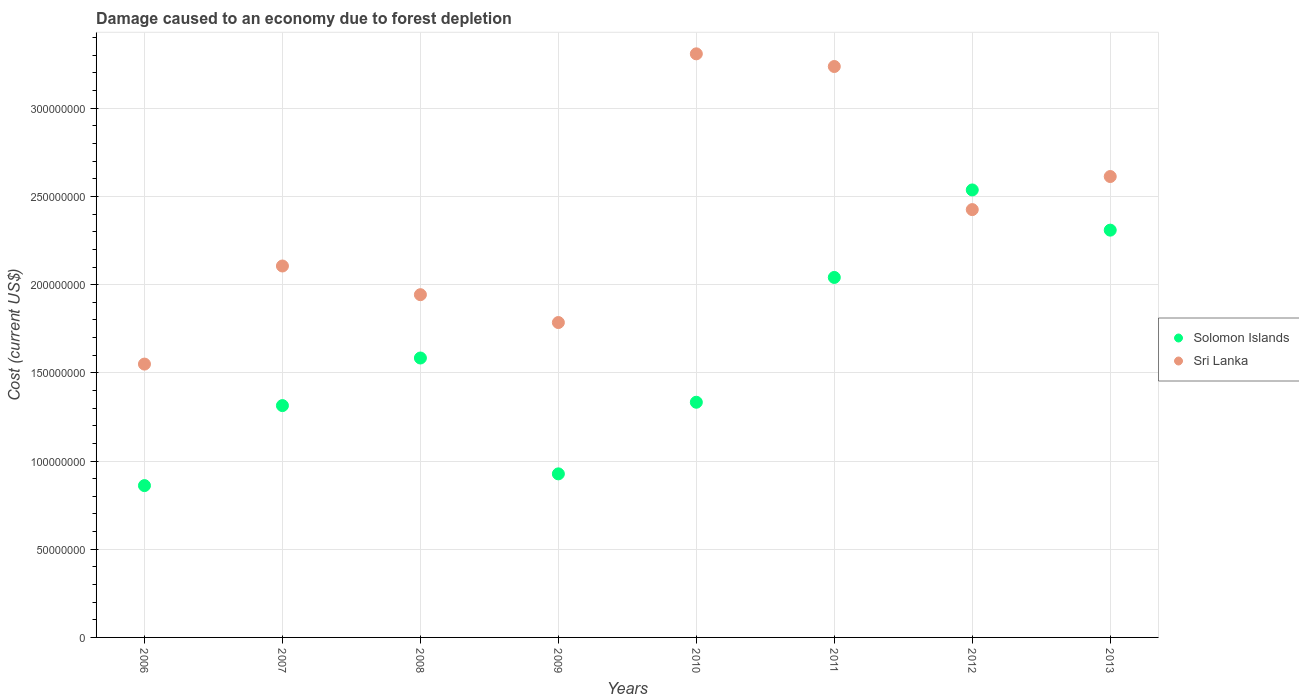Is the number of dotlines equal to the number of legend labels?
Provide a short and direct response. Yes. What is the cost of damage caused due to forest depletion in Solomon Islands in 2010?
Your answer should be very brief. 1.33e+08. Across all years, what is the maximum cost of damage caused due to forest depletion in Solomon Islands?
Make the answer very short. 2.54e+08. Across all years, what is the minimum cost of damage caused due to forest depletion in Solomon Islands?
Give a very brief answer. 8.61e+07. In which year was the cost of damage caused due to forest depletion in Solomon Islands maximum?
Your answer should be very brief. 2012. What is the total cost of damage caused due to forest depletion in Sri Lanka in the graph?
Provide a short and direct response. 1.90e+09. What is the difference between the cost of damage caused due to forest depletion in Solomon Islands in 2006 and that in 2010?
Provide a short and direct response. -4.73e+07. What is the difference between the cost of damage caused due to forest depletion in Sri Lanka in 2006 and the cost of damage caused due to forest depletion in Solomon Islands in 2008?
Ensure brevity in your answer.  -3.45e+06. What is the average cost of damage caused due to forest depletion in Sri Lanka per year?
Keep it short and to the point. 2.37e+08. In the year 2011, what is the difference between the cost of damage caused due to forest depletion in Sri Lanka and cost of damage caused due to forest depletion in Solomon Islands?
Give a very brief answer. 1.20e+08. In how many years, is the cost of damage caused due to forest depletion in Solomon Islands greater than 150000000 US$?
Ensure brevity in your answer.  4. What is the ratio of the cost of damage caused due to forest depletion in Sri Lanka in 2009 to that in 2011?
Provide a succinct answer. 0.55. Is the cost of damage caused due to forest depletion in Solomon Islands in 2009 less than that in 2011?
Keep it short and to the point. Yes. Is the difference between the cost of damage caused due to forest depletion in Sri Lanka in 2006 and 2010 greater than the difference between the cost of damage caused due to forest depletion in Solomon Islands in 2006 and 2010?
Give a very brief answer. No. What is the difference between the highest and the second highest cost of damage caused due to forest depletion in Solomon Islands?
Give a very brief answer. 2.28e+07. What is the difference between the highest and the lowest cost of damage caused due to forest depletion in Solomon Islands?
Ensure brevity in your answer.  1.68e+08. In how many years, is the cost of damage caused due to forest depletion in Sri Lanka greater than the average cost of damage caused due to forest depletion in Sri Lanka taken over all years?
Ensure brevity in your answer.  4. Is the sum of the cost of damage caused due to forest depletion in Solomon Islands in 2008 and 2011 greater than the maximum cost of damage caused due to forest depletion in Sri Lanka across all years?
Your response must be concise. Yes. Is the cost of damage caused due to forest depletion in Solomon Islands strictly greater than the cost of damage caused due to forest depletion in Sri Lanka over the years?
Offer a terse response. No. How many years are there in the graph?
Ensure brevity in your answer.  8. Are the values on the major ticks of Y-axis written in scientific E-notation?
Provide a short and direct response. No. Does the graph contain grids?
Give a very brief answer. Yes. Where does the legend appear in the graph?
Provide a succinct answer. Center right. What is the title of the graph?
Give a very brief answer. Damage caused to an economy due to forest depletion. What is the label or title of the Y-axis?
Your response must be concise. Cost (current US$). What is the Cost (current US$) of Solomon Islands in 2006?
Keep it short and to the point. 8.61e+07. What is the Cost (current US$) of Sri Lanka in 2006?
Offer a very short reply. 1.55e+08. What is the Cost (current US$) of Solomon Islands in 2007?
Your response must be concise. 1.31e+08. What is the Cost (current US$) in Sri Lanka in 2007?
Your answer should be compact. 2.11e+08. What is the Cost (current US$) in Solomon Islands in 2008?
Provide a short and direct response. 1.58e+08. What is the Cost (current US$) in Sri Lanka in 2008?
Your answer should be compact. 1.94e+08. What is the Cost (current US$) of Solomon Islands in 2009?
Make the answer very short. 9.27e+07. What is the Cost (current US$) in Sri Lanka in 2009?
Your answer should be very brief. 1.79e+08. What is the Cost (current US$) of Solomon Islands in 2010?
Ensure brevity in your answer.  1.33e+08. What is the Cost (current US$) in Sri Lanka in 2010?
Your response must be concise. 3.31e+08. What is the Cost (current US$) in Solomon Islands in 2011?
Ensure brevity in your answer.  2.04e+08. What is the Cost (current US$) of Sri Lanka in 2011?
Your answer should be compact. 3.24e+08. What is the Cost (current US$) in Solomon Islands in 2012?
Provide a succinct answer. 2.54e+08. What is the Cost (current US$) in Sri Lanka in 2012?
Your response must be concise. 2.43e+08. What is the Cost (current US$) in Solomon Islands in 2013?
Offer a very short reply. 2.31e+08. What is the Cost (current US$) in Sri Lanka in 2013?
Keep it short and to the point. 2.61e+08. Across all years, what is the maximum Cost (current US$) of Solomon Islands?
Your response must be concise. 2.54e+08. Across all years, what is the maximum Cost (current US$) in Sri Lanka?
Provide a succinct answer. 3.31e+08. Across all years, what is the minimum Cost (current US$) in Solomon Islands?
Offer a terse response. 8.61e+07. Across all years, what is the minimum Cost (current US$) in Sri Lanka?
Keep it short and to the point. 1.55e+08. What is the total Cost (current US$) in Solomon Islands in the graph?
Provide a succinct answer. 1.29e+09. What is the total Cost (current US$) in Sri Lanka in the graph?
Keep it short and to the point. 1.90e+09. What is the difference between the Cost (current US$) in Solomon Islands in 2006 and that in 2007?
Keep it short and to the point. -4.54e+07. What is the difference between the Cost (current US$) of Sri Lanka in 2006 and that in 2007?
Ensure brevity in your answer.  -5.56e+07. What is the difference between the Cost (current US$) in Solomon Islands in 2006 and that in 2008?
Your answer should be very brief. -7.23e+07. What is the difference between the Cost (current US$) in Sri Lanka in 2006 and that in 2008?
Make the answer very short. -3.93e+07. What is the difference between the Cost (current US$) in Solomon Islands in 2006 and that in 2009?
Your answer should be compact. -6.65e+06. What is the difference between the Cost (current US$) of Sri Lanka in 2006 and that in 2009?
Your answer should be very brief. -2.36e+07. What is the difference between the Cost (current US$) of Solomon Islands in 2006 and that in 2010?
Your answer should be very brief. -4.73e+07. What is the difference between the Cost (current US$) of Sri Lanka in 2006 and that in 2010?
Give a very brief answer. -1.76e+08. What is the difference between the Cost (current US$) in Solomon Islands in 2006 and that in 2011?
Your answer should be very brief. -1.18e+08. What is the difference between the Cost (current US$) of Sri Lanka in 2006 and that in 2011?
Provide a short and direct response. -1.69e+08. What is the difference between the Cost (current US$) of Solomon Islands in 2006 and that in 2012?
Provide a succinct answer. -1.68e+08. What is the difference between the Cost (current US$) in Sri Lanka in 2006 and that in 2012?
Your answer should be very brief. -8.76e+07. What is the difference between the Cost (current US$) of Solomon Islands in 2006 and that in 2013?
Give a very brief answer. -1.45e+08. What is the difference between the Cost (current US$) of Sri Lanka in 2006 and that in 2013?
Provide a succinct answer. -1.06e+08. What is the difference between the Cost (current US$) in Solomon Islands in 2007 and that in 2008?
Your response must be concise. -2.70e+07. What is the difference between the Cost (current US$) in Sri Lanka in 2007 and that in 2008?
Provide a short and direct response. 1.63e+07. What is the difference between the Cost (current US$) of Solomon Islands in 2007 and that in 2009?
Your answer should be compact. 3.87e+07. What is the difference between the Cost (current US$) in Sri Lanka in 2007 and that in 2009?
Keep it short and to the point. 3.21e+07. What is the difference between the Cost (current US$) of Solomon Islands in 2007 and that in 2010?
Offer a terse response. -1.90e+06. What is the difference between the Cost (current US$) in Sri Lanka in 2007 and that in 2010?
Offer a very short reply. -1.20e+08. What is the difference between the Cost (current US$) in Solomon Islands in 2007 and that in 2011?
Provide a succinct answer. -7.27e+07. What is the difference between the Cost (current US$) in Sri Lanka in 2007 and that in 2011?
Your answer should be compact. -1.13e+08. What is the difference between the Cost (current US$) in Solomon Islands in 2007 and that in 2012?
Your answer should be very brief. -1.22e+08. What is the difference between the Cost (current US$) of Sri Lanka in 2007 and that in 2012?
Your answer should be compact. -3.20e+07. What is the difference between the Cost (current US$) of Solomon Islands in 2007 and that in 2013?
Your answer should be very brief. -9.95e+07. What is the difference between the Cost (current US$) of Sri Lanka in 2007 and that in 2013?
Give a very brief answer. -5.07e+07. What is the difference between the Cost (current US$) in Solomon Islands in 2008 and that in 2009?
Ensure brevity in your answer.  6.57e+07. What is the difference between the Cost (current US$) of Sri Lanka in 2008 and that in 2009?
Offer a very short reply. 1.58e+07. What is the difference between the Cost (current US$) in Solomon Islands in 2008 and that in 2010?
Offer a very short reply. 2.51e+07. What is the difference between the Cost (current US$) in Sri Lanka in 2008 and that in 2010?
Provide a succinct answer. -1.37e+08. What is the difference between the Cost (current US$) in Solomon Islands in 2008 and that in 2011?
Ensure brevity in your answer.  -4.57e+07. What is the difference between the Cost (current US$) in Sri Lanka in 2008 and that in 2011?
Give a very brief answer. -1.29e+08. What is the difference between the Cost (current US$) in Solomon Islands in 2008 and that in 2012?
Provide a succinct answer. -9.53e+07. What is the difference between the Cost (current US$) of Sri Lanka in 2008 and that in 2012?
Keep it short and to the point. -4.82e+07. What is the difference between the Cost (current US$) of Solomon Islands in 2008 and that in 2013?
Give a very brief answer. -7.25e+07. What is the difference between the Cost (current US$) in Sri Lanka in 2008 and that in 2013?
Make the answer very short. -6.70e+07. What is the difference between the Cost (current US$) of Solomon Islands in 2009 and that in 2010?
Provide a short and direct response. -4.06e+07. What is the difference between the Cost (current US$) in Sri Lanka in 2009 and that in 2010?
Your answer should be compact. -1.52e+08. What is the difference between the Cost (current US$) of Solomon Islands in 2009 and that in 2011?
Your answer should be compact. -1.11e+08. What is the difference between the Cost (current US$) of Sri Lanka in 2009 and that in 2011?
Make the answer very short. -1.45e+08. What is the difference between the Cost (current US$) of Solomon Islands in 2009 and that in 2012?
Give a very brief answer. -1.61e+08. What is the difference between the Cost (current US$) of Sri Lanka in 2009 and that in 2012?
Provide a short and direct response. -6.40e+07. What is the difference between the Cost (current US$) in Solomon Islands in 2009 and that in 2013?
Give a very brief answer. -1.38e+08. What is the difference between the Cost (current US$) of Sri Lanka in 2009 and that in 2013?
Ensure brevity in your answer.  -8.28e+07. What is the difference between the Cost (current US$) in Solomon Islands in 2010 and that in 2011?
Offer a very short reply. -7.07e+07. What is the difference between the Cost (current US$) of Sri Lanka in 2010 and that in 2011?
Offer a very short reply. 7.18e+06. What is the difference between the Cost (current US$) of Solomon Islands in 2010 and that in 2012?
Provide a succinct answer. -1.20e+08. What is the difference between the Cost (current US$) of Sri Lanka in 2010 and that in 2012?
Provide a succinct answer. 8.83e+07. What is the difference between the Cost (current US$) of Solomon Islands in 2010 and that in 2013?
Make the answer very short. -9.76e+07. What is the difference between the Cost (current US$) in Sri Lanka in 2010 and that in 2013?
Your answer should be very brief. 6.96e+07. What is the difference between the Cost (current US$) of Solomon Islands in 2011 and that in 2012?
Provide a succinct answer. -4.96e+07. What is the difference between the Cost (current US$) in Sri Lanka in 2011 and that in 2012?
Offer a very short reply. 8.11e+07. What is the difference between the Cost (current US$) in Solomon Islands in 2011 and that in 2013?
Your response must be concise. -2.68e+07. What is the difference between the Cost (current US$) of Sri Lanka in 2011 and that in 2013?
Your response must be concise. 6.24e+07. What is the difference between the Cost (current US$) in Solomon Islands in 2012 and that in 2013?
Give a very brief answer. 2.28e+07. What is the difference between the Cost (current US$) in Sri Lanka in 2012 and that in 2013?
Your answer should be compact. -1.87e+07. What is the difference between the Cost (current US$) in Solomon Islands in 2006 and the Cost (current US$) in Sri Lanka in 2007?
Give a very brief answer. -1.24e+08. What is the difference between the Cost (current US$) of Solomon Islands in 2006 and the Cost (current US$) of Sri Lanka in 2008?
Your answer should be compact. -1.08e+08. What is the difference between the Cost (current US$) of Solomon Islands in 2006 and the Cost (current US$) of Sri Lanka in 2009?
Offer a very short reply. -9.24e+07. What is the difference between the Cost (current US$) in Solomon Islands in 2006 and the Cost (current US$) in Sri Lanka in 2010?
Give a very brief answer. -2.45e+08. What is the difference between the Cost (current US$) in Solomon Islands in 2006 and the Cost (current US$) in Sri Lanka in 2011?
Your answer should be compact. -2.38e+08. What is the difference between the Cost (current US$) in Solomon Islands in 2006 and the Cost (current US$) in Sri Lanka in 2012?
Your response must be concise. -1.56e+08. What is the difference between the Cost (current US$) in Solomon Islands in 2006 and the Cost (current US$) in Sri Lanka in 2013?
Your answer should be very brief. -1.75e+08. What is the difference between the Cost (current US$) in Solomon Islands in 2007 and the Cost (current US$) in Sri Lanka in 2008?
Ensure brevity in your answer.  -6.29e+07. What is the difference between the Cost (current US$) in Solomon Islands in 2007 and the Cost (current US$) in Sri Lanka in 2009?
Your answer should be very brief. -4.71e+07. What is the difference between the Cost (current US$) in Solomon Islands in 2007 and the Cost (current US$) in Sri Lanka in 2010?
Keep it short and to the point. -1.99e+08. What is the difference between the Cost (current US$) in Solomon Islands in 2007 and the Cost (current US$) in Sri Lanka in 2011?
Provide a short and direct response. -1.92e+08. What is the difference between the Cost (current US$) in Solomon Islands in 2007 and the Cost (current US$) in Sri Lanka in 2012?
Provide a succinct answer. -1.11e+08. What is the difference between the Cost (current US$) of Solomon Islands in 2007 and the Cost (current US$) of Sri Lanka in 2013?
Your response must be concise. -1.30e+08. What is the difference between the Cost (current US$) in Solomon Islands in 2008 and the Cost (current US$) in Sri Lanka in 2009?
Offer a terse response. -2.01e+07. What is the difference between the Cost (current US$) of Solomon Islands in 2008 and the Cost (current US$) of Sri Lanka in 2010?
Make the answer very short. -1.72e+08. What is the difference between the Cost (current US$) of Solomon Islands in 2008 and the Cost (current US$) of Sri Lanka in 2011?
Offer a terse response. -1.65e+08. What is the difference between the Cost (current US$) in Solomon Islands in 2008 and the Cost (current US$) in Sri Lanka in 2012?
Ensure brevity in your answer.  -8.41e+07. What is the difference between the Cost (current US$) of Solomon Islands in 2008 and the Cost (current US$) of Sri Lanka in 2013?
Your answer should be compact. -1.03e+08. What is the difference between the Cost (current US$) in Solomon Islands in 2009 and the Cost (current US$) in Sri Lanka in 2010?
Your response must be concise. -2.38e+08. What is the difference between the Cost (current US$) of Solomon Islands in 2009 and the Cost (current US$) of Sri Lanka in 2011?
Your answer should be compact. -2.31e+08. What is the difference between the Cost (current US$) in Solomon Islands in 2009 and the Cost (current US$) in Sri Lanka in 2012?
Your answer should be compact. -1.50e+08. What is the difference between the Cost (current US$) of Solomon Islands in 2009 and the Cost (current US$) of Sri Lanka in 2013?
Make the answer very short. -1.69e+08. What is the difference between the Cost (current US$) of Solomon Islands in 2010 and the Cost (current US$) of Sri Lanka in 2011?
Offer a very short reply. -1.90e+08. What is the difference between the Cost (current US$) in Solomon Islands in 2010 and the Cost (current US$) in Sri Lanka in 2012?
Make the answer very short. -1.09e+08. What is the difference between the Cost (current US$) of Solomon Islands in 2010 and the Cost (current US$) of Sri Lanka in 2013?
Your response must be concise. -1.28e+08. What is the difference between the Cost (current US$) of Solomon Islands in 2011 and the Cost (current US$) of Sri Lanka in 2012?
Make the answer very short. -3.85e+07. What is the difference between the Cost (current US$) in Solomon Islands in 2011 and the Cost (current US$) in Sri Lanka in 2013?
Your answer should be very brief. -5.72e+07. What is the difference between the Cost (current US$) in Solomon Islands in 2012 and the Cost (current US$) in Sri Lanka in 2013?
Offer a terse response. -7.60e+06. What is the average Cost (current US$) in Solomon Islands per year?
Provide a succinct answer. 1.61e+08. What is the average Cost (current US$) of Sri Lanka per year?
Offer a terse response. 2.37e+08. In the year 2006, what is the difference between the Cost (current US$) of Solomon Islands and Cost (current US$) of Sri Lanka?
Provide a short and direct response. -6.89e+07. In the year 2007, what is the difference between the Cost (current US$) in Solomon Islands and Cost (current US$) in Sri Lanka?
Your response must be concise. -7.91e+07. In the year 2008, what is the difference between the Cost (current US$) of Solomon Islands and Cost (current US$) of Sri Lanka?
Offer a terse response. -3.59e+07. In the year 2009, what is the difference between the Cost (current US$) in Solomon Islands and Cost (current US$) in Sri Lanka?
Give a very brief answer. -8.58e+07. In the year 2010, what is the difference between the Cost (current US$) in Solomon Islands and Cost (current US$) in Sri Lanka?
Ensure brevity in your answer.  -1.98e+08. In the year 2011, what is the difference between the Cost (current US$) in Solomon Islands and Cost (current US$) in Sri Lanka?
Give a very brief answer. -1.20e+08. In the year 2012, what is the difference between the Cost (current US$) of Solomon Islands and Cost (current US$) of Sri Lanka?
Your answer should be very brief. 1.11e+07. In the year 2013, what is the difference between the Cost (current US$) in Solomon Islands and Cost (current US$) in Sri Lanka?
Give a very brief answer. -3.04e+07. What is the ratio of the Cost (current US$) of Solomon Islands in 2006 to that in 2007?
Your answer should be very brief. 0.65. What is the ratio of the Cost (current US$) in Sri Lanka in 2006 to that in 2007?
Your answer should be very brief. 0.74. What is the ratio of the Cost (current US$) of Solomon Islands in 2006 to that in 2008?
Keep it short and to the point. 0.54. What is the ratio of the Cost (current US$) of Sri Lanka in 2006 to that in 2008?
Ensure brevity in your answer.  0.8. What is the ratio of the Cost (current US$) in Solomon Islands in 2006 to that in 2009?
Your answer should be compact. 0.93. What is the ratio of the Cost (current US$) of Sri Lanka in 2006 to that in 2009?
Offer a terse response. 0.87. What is the ratio of the Cost (current US$) in Solomon Islands in 2006 to that in 2010?
Provide a succinct answer. 0.65. What is the ratio of the Cost (current US$) of Sri Lanka in 2006 to that in 2010?
Offer a very short reply. 0.47. What is the ratio of the Cost (current US$) in Solomon Islands in 2006 to that in 2011?
Keep it short and to the point. 0.42. What is the ratio of the Cost (current US$) of Sri Lanka in 2006 to that in 2011?
Your response must be concise. 0.48. What is the ratio of the Cost (current US$) in Solomon Islands in 2006 to that in 2012?
Provide a succinct answer. 0.34. What is the ratio of the Cost (current US$) of Sri Lanka in 2006 to that in 2012?
Offer a terse response. 0.64. What is the ratio of the Cost (current US$) of Solomon Islands in 2006 to that in 2013?
Your response must be concise. 0.37. What is the ratio of the Cost (current US$) of Sri Lanka in 2006 to that in 2013?
Your answer should be compact. 0.59. What is the ratio of the Cost (current US$) of Solomon Islands in 2007 to that in 2008?
Ensure brevity in your answer.  0.83. What is the ratio of the Cost (current US$) in Sri Lanka in 2007 to that in 2008?
Offer a terse response. 1.08. What is the ratio of the Cost (current US$) of Solomon Islands in 2007 to that in 2009?
Your response must be concise. 1.42. What is the ratio of the Cost (current US$) in Sri Lanka in 2007 to that in 2009?
Offer a very short reply. 1.18. What is the ratio of the Cost (current US$) of Solomon Islands in 2007 to that in 2010?
Provide a short and direct response. 0.99. What is the ratio of the Cost (current US$) in Sri Lanka in 2007 to that in 2010?
Provide a short and direct response. 0.64. What is the ratio of the Cost (current US$) of Solomon Islands in 2007 to that in 2011?
Provide a short and direct response. 0.64. What is the ratio of the Cost (current US$) of Sri Lanka in 2007 to that in 2011?
Provide a short and direct response. 0.65. What is the ratio of the Cost (current US$) of Solomon Islands in 2007 to that in 2012?
Your answer should be very brief. 0.52. What is the ratio of the Cost (current US$) of Sri Lanka in 2007 to that in 2012?
Provide a succinct answer. 0.87. What is the ratio of the Cost (current US$) in Solomon Islands in 2007 to that in 2013?
Ensure brevity in your answer.  0.57. What is the ratio of the Cost (current US$) of Sri Lanka in 2007 to that in 2013?
Provide a short and direct response. 0.81. What is the ratio of the Cost (current US$) in Solomon Islands in 2008 to that in 2009?
Keep it short and to the point. 1.71. What is the ratio of the Cost (current US$) in Sri Lanka in 2008 to that in 2009?
Provide a succinct answer. 1.09. What is the ratio of the Cost (current US$) in Solomon Islands in 2008 to that in 2010?
Provide a succinct answer. 1.19. What is the ratio of the Cost (current US$) of Sri Lanka in 2008 to that in 2010?
Make the answer very short. 0.59. What is the ratio of the Cost (current US$) in Solomon Islands in 2008 to that in 2011?
Offer a very short reply. 0.78. What is the ratio of the Cost (current US$) of Sri Lanka in 2008 to that in 2011?
Offer a terse response. 0.6. What is the ratio of the Cost (current US$) of Solomon Islands in 2008 to that in 2012?
Offer a terse response. 0.62. What is the ratio of the Cost (current US$) in Sri Lanka in 2008 to that in 2012?
Provide a short and direct response. 0.8. What is the ratio of the Cost (current US$) in Solomon Islands in 2008 to that in 2013?
Provide a succinct answer. 0.69. What is the ratio of the Cost (current US$) of Sri Lanka in 2008 to that in 2013?
Your answer should be compact. 0.74. What is the ratio of the Cost (current US$) of Solomon Islands in 2009 to that in 2010?
Your response must be concise. 0.7. What is the ratio of the Cost (current US$) of Sri Lanka in 2009 to that in 2010?
Give a very brief answer. 0.54. What is the ratio of the Cost (current US$) in Solomon Islands in 2009 to that in 2011?
Ensure brevity in your answer.  0.45. What is the ratio of the Cost (current US$) of Sri Lanka in 2009 to that in 2011?
Keep it short and to the point. 0.55. What is the ratio of the Cost (current US$) in Solomon Islands in 2009 to that in 2012?
Your answer should be compact. 0.37. What is the ratio of the Cost (current US$) of Sri Lanka in 2009 to that in 2012?
Provide a succinct answer. 0.74. What is the ratio of the Cost (current US$) in Solomon Islands in 2009 to that in 2013?
Offer a terse response. 0.4. What is the ratio of the Cost (current US$) in Sri Lanka in 2009 to that in 2013?
Offer a very short reply. 0.68. What is the ratio of the Cost (current US$) of Solomon Islands in 2010 to that in 2011?
Provide a short and direct response. 0.65. What is the ratio of the Cost (current US$) in Sri Lanka in 2010 to that in 2011?
Provide a succinct answer. 1.02. What is the ratio of the Cost (current US$) in Solomon Islands in 2010 to that in 2012?
Offer a terse response. 0.53. What is the ratio of the Cost (current US$) of Sri Lanka in 2010 to that in 2012?
Offer a terse response. 1.36. What is the ratio of the Cost (current US$) of Solomon Islands in 2010 to that in 2013?
Offer a terse response. 0.58. What is the ratio of the Cost (current US$) in Sri Lanka in 2010 to that in 2013?
Provide a succinct answer. 1.27. What is the ratio of the Cost (current US$) of Solomon Islands in 2011 to that in 2012?
Offer a terse response. 0.8. What is the ratio of the Cost (current US$) in Sri Lanka in 2011 to that in 2012?
Provide a short and direct response. 1.33. What is the ratio of the Cost (current US$) in Solomon Islands in 2011 to that in 2013?
Provide a short and direct response. 0.88. What is the ratio of the Cost (current US$) of Sri Lanka in 2011 to that in 2013?
Offer a terse response. 1.24. What is the ratio of the Cost (current US$) in Solomon Islands in 2012 to that in 2013?
Offer a very short reply. 1.1. What is the ratio of the Cost (current US$) of Sri Lanka in 2012 to that in 2013?
Offer a very short reply. 0.93. What is the difference between the highest and the second highest Cost (current US$) of Solomon Islands?
Offer a terse response. 2.28e+07. What is the difference between the highest and the second highest Cost (current US$) in Sri Lanka?
Make the answer very short. 7.18e+06. What is the difference between the highest and the lowest Cost (current US$) in Solomon Islands?
Offer a very short reply. 1.68e+08. What is the difference between the highest and the lowest Cost (current US$) in Sri Lanka?
Your response must be concise. 1.76e+08. 